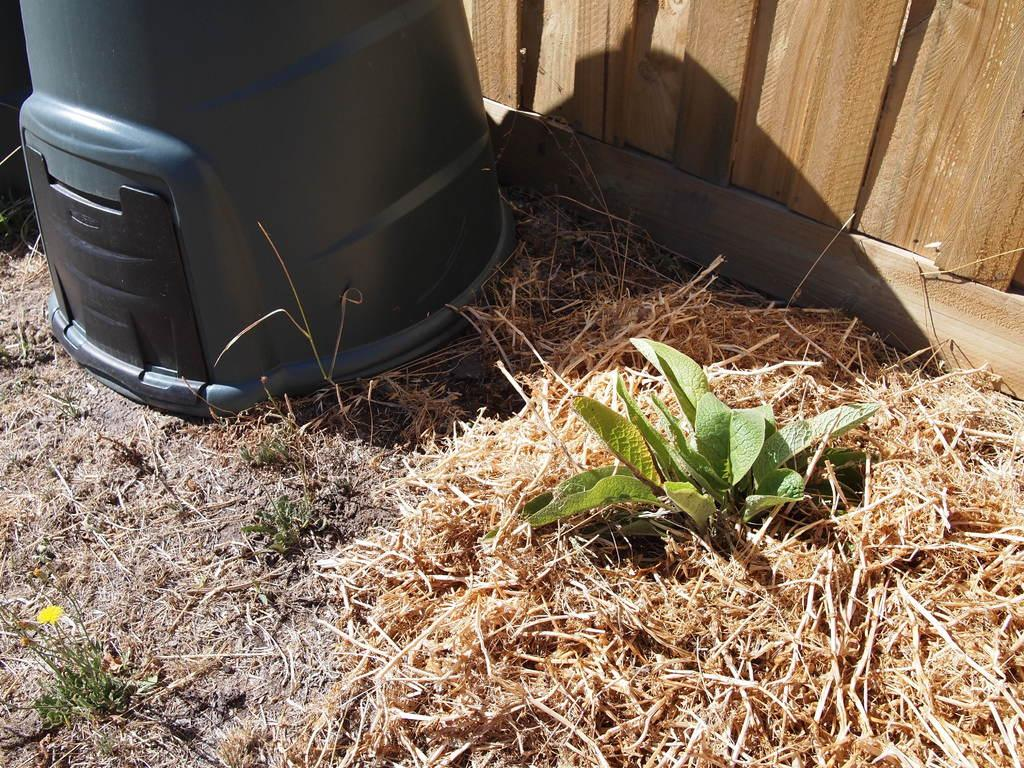What type of surface is at the bottom of the image? There is grass on the ground at the bottom of the image. What can be seen in the top left corner of the image? There is a black item in the top left corner of the image. What type of material is used for the wall in the top right corner of the image? There is a wooden wall in the top right corner of the image. How does the hen use the force to break the wooden wall in the image? There is no hen or force present in the image; it only features grass, a black item, and a wooden wall. 